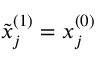<formula> <loc_0><loc_0><loc_500><loc_500>\tilde { x } _ { j } ^ { ( 1 ) } = x _ { j } ^ { ( 0 ) }</formula> 